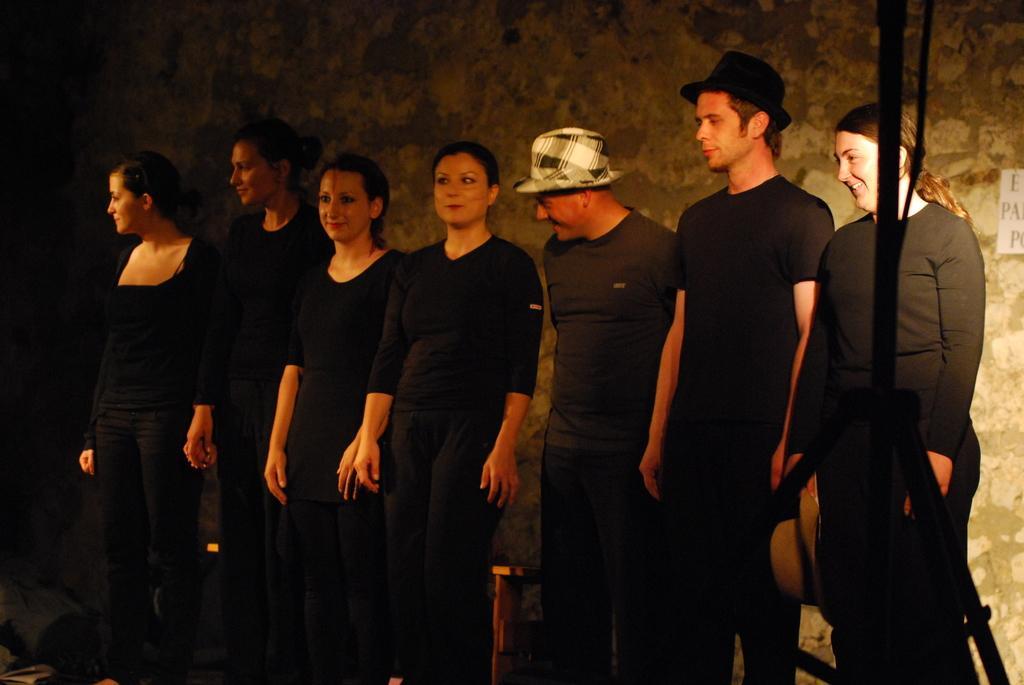How would you summarize this image in a sentence or two? In this picture I can see a number of people wearing black dress and standing. I can see the wall in the background. 